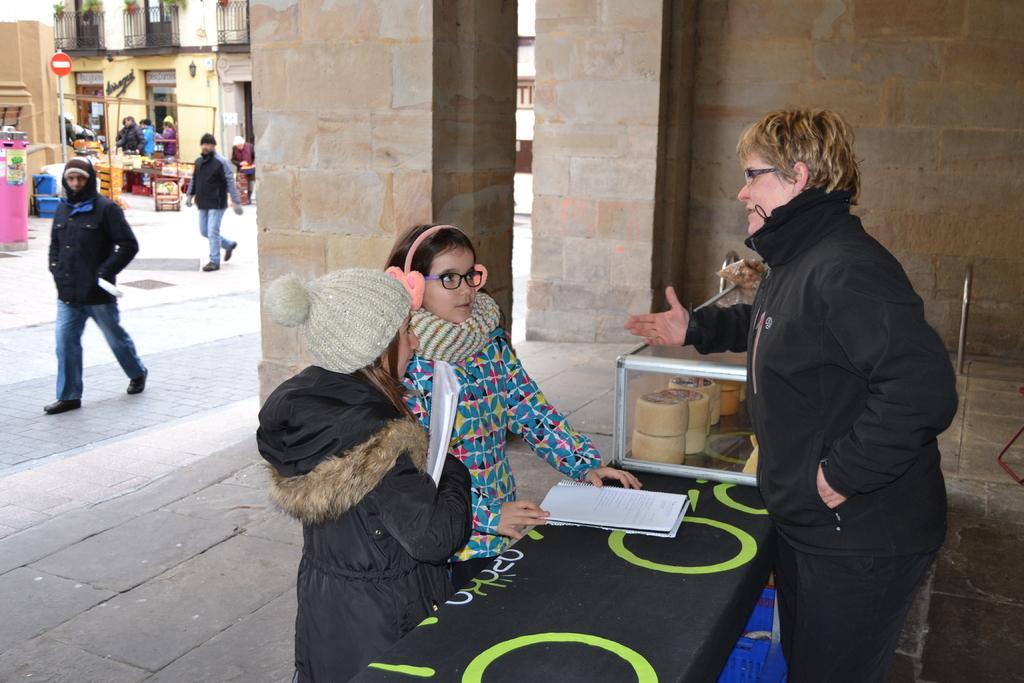In one or two sentences, can you explain what this image depicts? There are groups of people standing and few people walking. These are the pillars. I can see a table, which is covered with a cloth. This looks like a basket, which is under the table. I can see few items, which are kept in the glass box. This looks like a stall. I can see the buildings with the doors. Here is a signboard, which is attached to the pole. On the left side of the image, that looks like an object. 